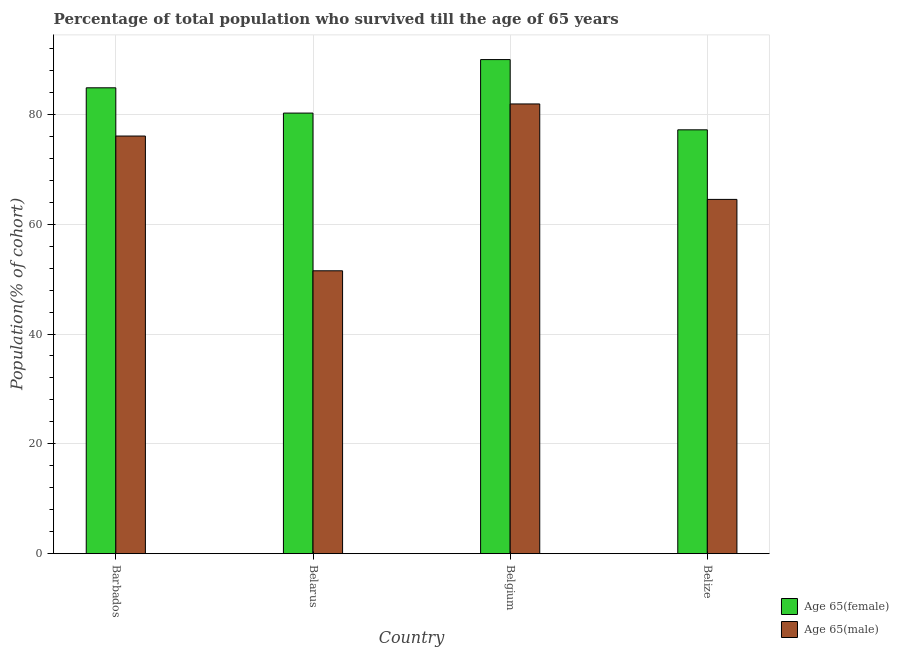How many different coloured bars are there?
Give a very brief answer. 2. How many groups of bars are there?
Give a very brief answer. 4. How many bars are there on the 4th tick from the left?
Give a very brief answer. 2. How many bars are there on the 1st tick from the right?
Make the answer very short. 2. What is the label of the 1st group of bars from the left?
Provide a short and direct response. Barbados. What is the percentage of male population who survived till age of 65 in Belize?
Ensure brevity in your answer.  64.52. Across all countries, what is the maximum percentage of female population who survived till age of 65?
Offer a terse response. 89.99. Across all countries, what is the minimum percentage of female population who survived till age of 65?
Your response must be concise. 77.19. In which country was the percentage of male population who survived till age of 65 maximum?
Make the answer very short. Belgium. In which country was the percentage of male population who survived till age of 65 minimum?
Keep it short and to the point. Belarus. What is the total percentage of male population who survived till age of 65 in the graph?
Give a very brief answer. 274.01. What is the difference between the percentage of male population who survived till age of 65 in Barbados and that in Belgium?
Your answer should be very brief. -5.84. What is the difference between the percentage of female population who survived till age of 65 in Belize and the percentage of male population who survived till age of 65 in Belgium?
Provide a short and direct response. -4.71. What is the average percentage of female population who survived till age of 65 per country?
Ensure brevity in your answer.  83.07. What is the difference between the percentage of male population who survived till age of 65 and percentage of female population who survived till age of 65 in Belarus?
Your response must be concise. -28.73. In how many countries, is the percentage of male population who survived till age of 65 greater than 16 %?
Your answer should be very brief. 4. What is the ratio of the percentage of female population who survived till age of 65 in Barbados to that in Belize?
Give a very brief answer. 1.1. Is the percentage of female population who survived till age of 65 in Barbados less than that in Belarus?
Your response must be concise. No. What is the difference between the highest and the second highest percentage of male population who survived till age of 65?
Your response must be concise. 5.84. What is the difference between the highest and the lowest percentage of male population who survived till age of 65?
Provide a short and direct response. 30.39. In how many countries, is the percentage of male population who survived till age of 65 greater than the average percentage of male population who survived till age of 65 taken over all countries?
Give a very brief answer. 2. What does the 2nd bar from the left in Belgium represents?
Provide a succinct answer. Age 65(male). What does the 2nd bar from the right in Belgium represents?
Offer a terse response. Age 65(female). How many bars are there?
Make the answer very short. 8. Are the values on the major ticks of Y-axis written in scientific E-notation?
Provide a short and direct response. No. Does the graph contain any zero values?
Your answer should be compact. No. Where does the legend appear in the graph?
Ensure brevity in your answer.  Bottom right. How many legend labels are there?
Offer a very short reply. 2. How are the legend labels stacked?
Give a very brief answer. Vertical. What is the title of the graph?
Your answer should be very brief. Percentage of total population who survived till the age of 65 years. What is the label or title of the Y-axis?
Make the answer very short. Population(% of cohort). What is the Population(% of cohort) in Age 65(female) in Barbados?
Make the answer very short. 84.85. What is the Population(% of cohort) in Age 65(male) in Barbados?
Your answer should be compact. 76.06. What is the Population(% of cohort) of Age 65(female) in Belarus?
Ensure brevity in your answer.  80.24. What is the Population(% of cohort) of Age 65(male) in Belarus?
Offer a very short reply. 51.52. What is the Population(% of cohort) of Age 65(female) in Belgium?
Provide a succinct answer. 89.99. What is the Population(% of cohort) of Age 65(male) in Belgium?
Ensure brevity in your answer.  81.91. What is the Population(% of cohort) in Age 65(female) in Belize?
Give a very brief answer. 77.19. What is the Population(% of cohort) of Age 65(male) in Belize?
Your response must be concise. 64.52. Across all countries, what is the maximum Population(% of cohort) in Age 65(female)?
Give a very brief answer. 89.99. Across all countries, what is the maximum Population(% of cohort) of Age 65(male)?
Give a very brief answer. 81.91. Across all countries, what is the minimum Population(% of cohort) in Age 65(female)?
Your answer should be very brief. 77.19. Across all countries, what is the minimum Population(% of cohort) of Age 65(male)?
Your answer should be very brief. 51.52. What is the total Population(% of cohort) in Age 65(female) in the graph?
Offer a terse response. 332.27. What is the total Population(% of cohort) of Age 65(male) in the graph?
Make the answer very short. 274.01. What is the difference between the Population(% of cohort) in Age 65(female) in Barbados and that in Belarus?
Provide a short and direct response. 4.6. What is the difference between the Population(% of cohort) in Age 65(male) in Barbados and that in Belarus?
Give a very brief answer. 24.54. What is the difference between the Population(% of cohort) in Age 65(female) in Barbados and that in Belgium?
Offer a terse response. -5.14. What is the difference between the Population(% of cohort) of Age 65(male) in Barbados and that in Belgium?
Offer a very short reply. -5.84. What is the difference between the Population(% of cohort) in Age 65(female) in Barbados and that in Belize?
Ensure brevity in your answer.  7.65. What is the difference between the Population(% of cohort) in Age 65(male) in Barbados and that in Belize?
Give a very brief answer. 11.54. What is the difference between the Population(% of cohort) of Age 65(female) in Belarus and that in Belgium?
Your answer should be compact. -9.74. What is the difference between the Population(% of cohort) in Age 65(male) in Belarus and that in Belgium?
Your response must be concise. -30.39. What is the difference between the Population(% of cohort) of Age 65(female) in Belarus and that in Belize?
Offer a very short reply. 3.05. What is the difference between the Population(% of cohort) of Age 65(male) in Belarus and that in Belize?
Your answer should be compact. -13. What is the difference between the Population(% of cohort) in Age 65(female) in Belgium and that in Belize?
Your response must be concise. 12.8. What is the difference between the Population(% of cohort) in Age 65(male) in Belgium and that in Belize?
Keep it short and to the point. 17.39. What is the difference between the Population(% of cohort) in Age 65(female) in Barbados and the Population(% of cohort) in Age 65(male) in Belarus?
Offer a very short reply. 33.33. What is the difference between the Population(% of cohort) in Age 65(female) in Barbados and the Population(% of cohort) in Age 65(male) in Belgium?
Offer a terse response. 2.94. What is the difference between the Population(% of cohort) in Age 65(female) in Barbados and the Population(% of cohort) in Age 65(male) in Belize?
Your answer should be compact. 20.32. What is the difference between the Population(% of cohort) of Age 65(female) in Belarus and the Population(% of cohort) of Age 65(male) in Belgium?
Ensure brevity in your answer.  -1.66. What is the difference between the Population(% of cohort) in Age 65(female) in Belarus and the Population(% of cohort) in Age 65(male) in Belize?
Your response must be concise. 15.72. What is the difference between the Population(% of cohort) of Age 65(female) in Belgium and the Population(% of cohort) of Age 65(male) in Belize?
Provide a succinct answer. 25.47. What is the average Population(% of cohort) in Age 65(female) per country?
Keep it short and to the point. 83.07. What is the average Population(% of cohort) of Age 65(male) per country?
Your answer should be very brief. 68.5. What is the difference between the Population(% of cohort) in Age 65(female) and Population(% of cohort) in Age 65(male) in Barbados?
Keep it short and to the point. 8.78. What is the difference between the Population(% of cohort) of Age 65(female) and Population(% of cohort) of Age 65(male) in Belarus?
Keep it short and to the point. 28.73. What is the difference between the Population(% of cohort) of Age 65(female) and Population(% of cohort) of Age 65(male) in Belgium?
Make the answer very short. 8.08. What is the difference between the Population(% of cohort) in Age 65(female) and Population(% of cohort) in Age 65(male) in Belize?
Your answer should be very brief. 12.67. What is the ratio of the Population(% of cohort) in Age 65(female) in Barbados to that in Belarus?
Provide a short and direct response. 1.06. What is the ratio of the Population(% of cohort) in Age 65(male) in Barbados to that in Belarus?
Offer a terse response. 1.48. What is the ratio of the Population(% of cohort) in Age 65(female) in Barbados to that in Belgium?
Make the answer very short. 0.94. What is the ratio of the Population(% of cohort) of Age 65(female) in Barbados to that in Belize?
Make the answer very short. 1.1. What is the ratio of the Population(% of cohort) in Age 65(male) in Barbados to that in Belize?
Make the answer very short. 1.18. What is the ratio of the Population(% of cohort) of Age 65(female) in Belarus to that in Belgium?
Ensure brevity in your answer.  0.89. What is the ratio of the Population(% of cohort) of Age 65(male) in Belarus to that in Belgium?
Your response must be concise. 0.63. What is the ratio of the Population(% of cohort) of Age 65(female) in Belarus to that in Belize?
Provide a succinct answer. 1.04. What is the ratio of the Population(% of cohort) in Age 65(male) in Belarus to that in Belize?
Make the answer very short. 0.8. What is the ratio of the Population(% of cohort) of Age 65(female) in Belgium to that in Belize?
Provide a succinct answer. 1.17. What is the ratio of the Population(% of cohort) in Age 65(male) in Belgium to that in Belize?
Make the answer very short. 1.27. What is the difference between the highest and the second highest Population(% of cohort) of Age 65(female)?
Your answer should be compact. 5.14. What is the difference between the highest and the second highest Population(% of cohort) of Age 65(male)?
Your response must be concise. 5.84. What is the difference between the highest and the lowest Population(% of cohort) of Age 65(female)?
Make the answer very short. 12.8. What is the difference between the highest and the lowest Population(% of cohort) of Age 65(male)?
Offer a terse response. 30.39. 